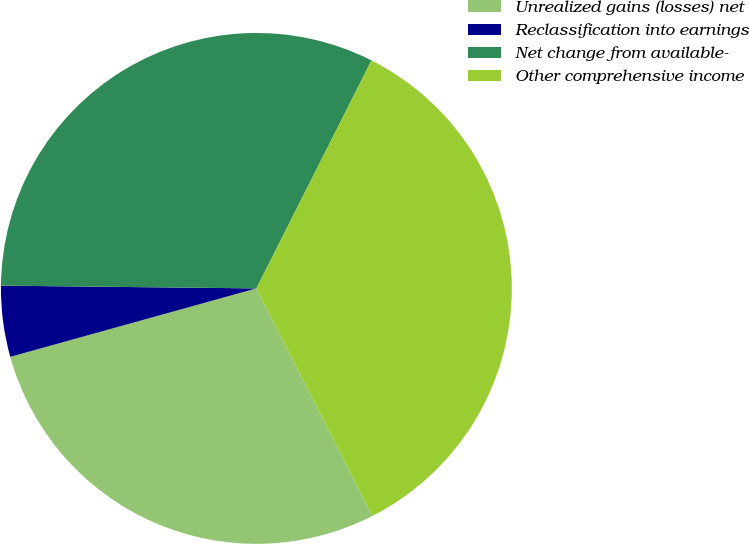Convert chart to OTSL. <chart><loc_0><loc_0><loc_500><loc_500><pie_chart><fcel>Unrealized gains (losses) net<fcel>Reclassification into earnings<fcel>Net change from available-<fcel>Other comprehensive income<nl><fcel>28.19%<fcel>4.49%<fcel>32.27%<fcel>35.05%<nl></chart> 